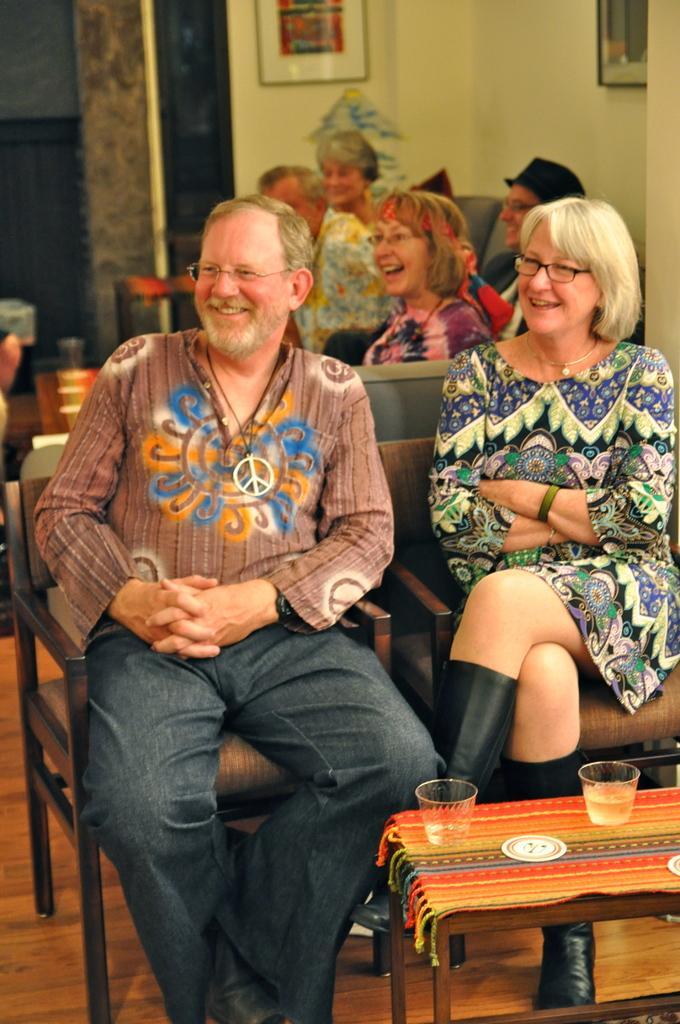Could you give a brief overview of what you see in this image? This picture shows a group of people seated on the chairs and we see two cups on the table 